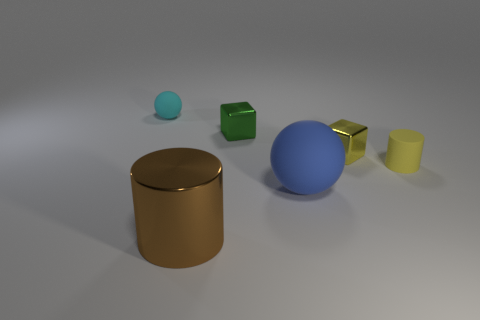Add 2 balls. How many objects exist? 8 Subtract all cyan cubes. How many cyan cylinders are left? 0 Add 3 brown metallic cylinders. How many brown metallic cylinders exist? 4 Subtract all cyan spheres. How many spheres are left? 1 Subtract 0 brown spheres. How many objects are left? 6 Subtract 2 cylinders. How many cylinders are left? 0 Subtract all purple cylinders. Subtract all blue spheres. How many cylinders are left? 2 Subtract all tiny matte things. Subtract all yellow rubber cylinders. How many objects are left? 3 Add 6 spheres. How many spheres are left? 8 